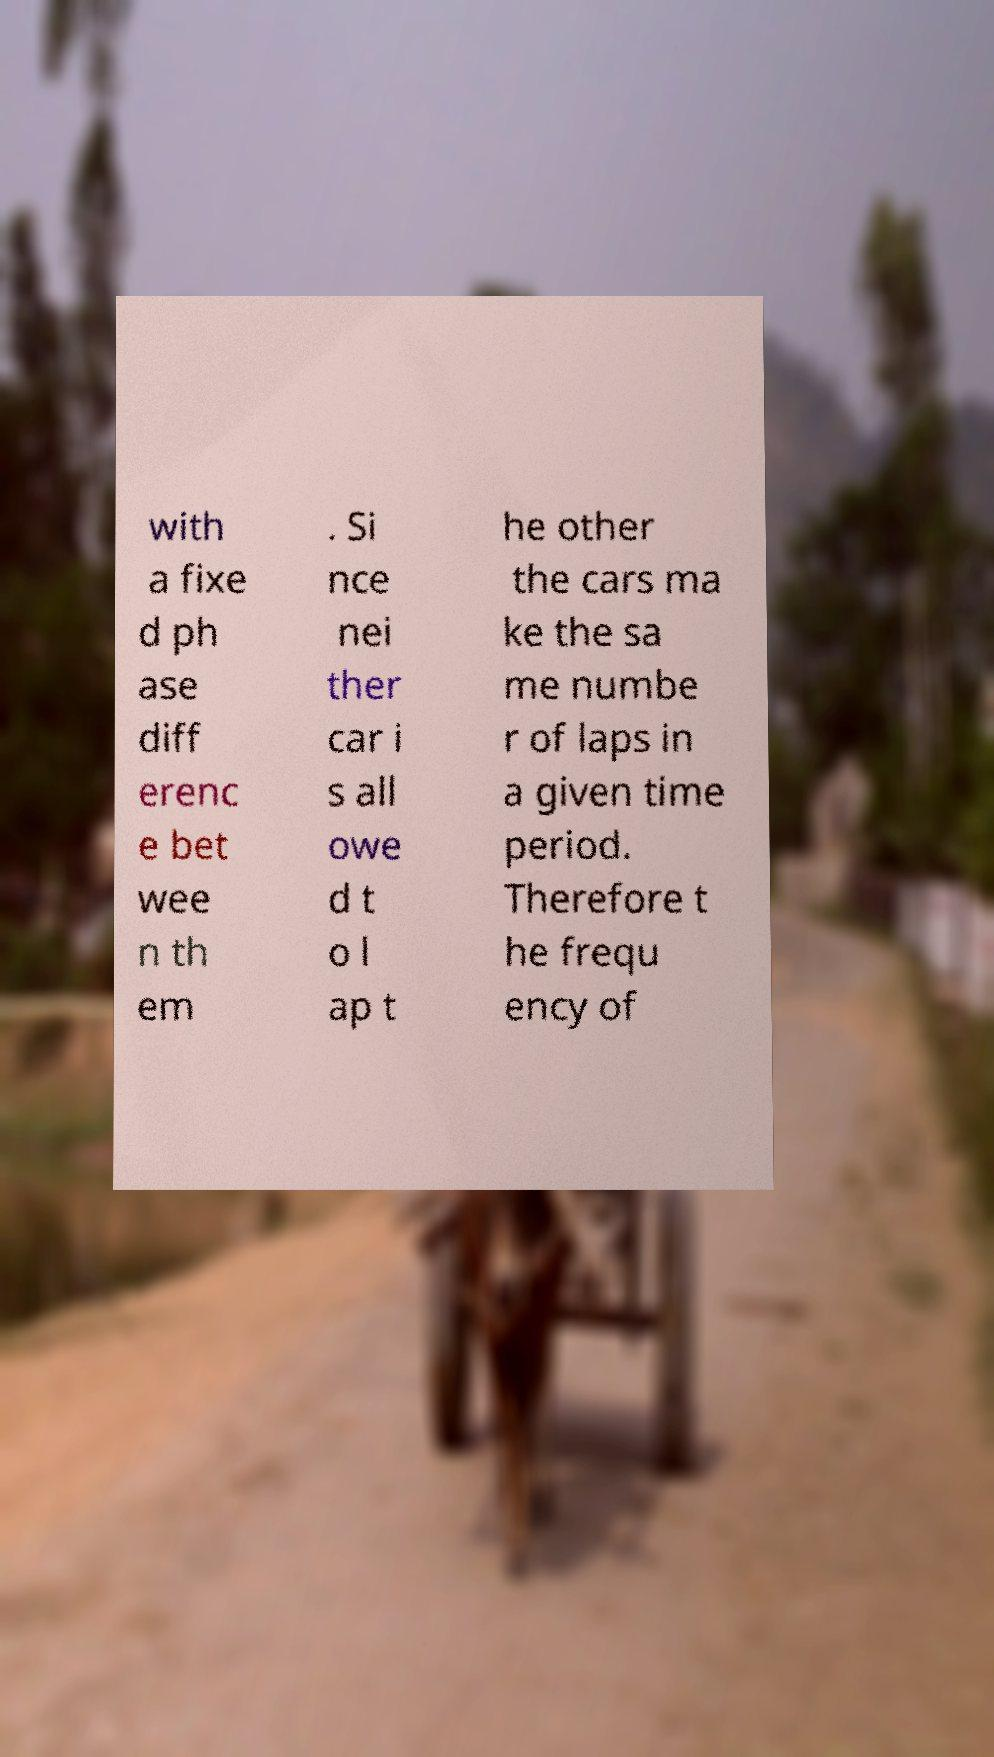Could you assist in decoding the text presented in this image and type it out clearly? with a fixe d ph ase diff erenc e bet wee n th em . Si nce nei ther car i s all owe d t o l ap t he other the cars ma ke the sa me numbe r of laps in a given time period. Therefore t he frequ ency of 